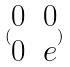<formula> <loc_0><loc_0><loc_500><loc_500>( \begin{matrix} 0 & 0 \\ 0 & e \end{matrix} )</formula> 